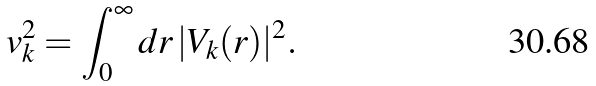Convert formula to latex. <formula><loc_0><loc_0><loc_500><loc_500>v _ { k } ^ { 2 } = \int ^ { \infty } _ { 0 } d r \, | V _ { k } ( r ) | ^ { 2 } .</formula> 